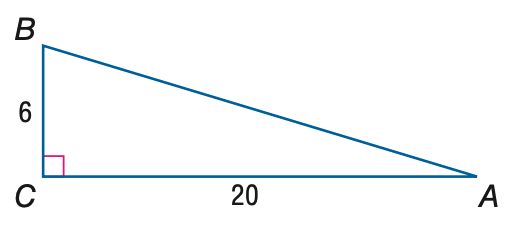Question: Find the measure of \angle A to the nearest tenth.
Choices:
A. 16.7
B. 17.5
C. 72.5
D. 73.3
Answer with the letter. Answer: A 